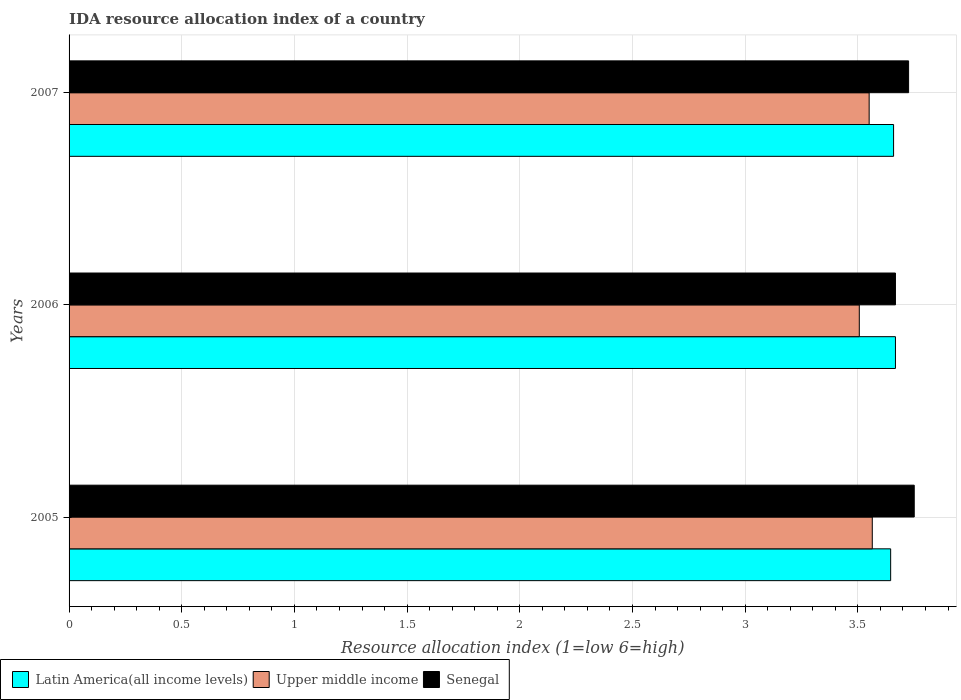How many groups of bars are there?
Make the answer very short. 3. Are the number of bars on each tick of the Y-axis equal?
Your answer should be compact. Yes. In how many cases, is the number of bars for a given year not equal to the number of legend labels?
Your answer should be very brief. 0. What is the IDA resource allocation index in Upper middle income in 2007?
Ensure brevity in your answer.  3.55. Across all years, what is the maximum IDA resource allocation index in Upper middle income?
Keep it short and to the point. 3.56. Across all years, what is the minimum IDA resource allocation index in Senegal?
Provide a succinct answer. 3.67. In which year was the IDA resource allocation index in Latin America(all income levels) minimum?
Your response must be concise. 2005. What is the total IDA resource allocation index in Senegal in the graph?
Keep it short and to the point. 11.14. What is the difference between the IDA resource allocation index in Senegal in 2006 and that in 2007?
Ensure brevity in your answer.  -0.06. What is the difference between the IDA resource allocation index in Latin America(all income levels) in 2006 and the IDA resource allocation index in Upper middle income in 2005?
Give a very brief answer. 0.1. What is the average IDA resource allocation index in Upper middle income per year?
Provide a succinct answer. 3.54. In the year 2005, what is the difference between the IDA resource allocation index in Upper middle income and IDA resource allocation index in Latin America(all income levels)?
Keep it short and to the point. -0.08. In how many years, is the IDA resource allocation index in Senegal greater than 2.8 ?
Offer a terse response. 3. What is the ratio of the IDA resource allocation index in Senegal in 2005 to that in 2007?
Offer a very short reply. 1.01. Is the IDA resource allocation index in Latin America(all income levels) in 2005 less than that in 2006?
Give a very brief answer. Yes. Is the difference between the IDA resource allocation index in Upper middle income in 2005 and 2007 greater than the difference between the IDA resource allocation index in Latin America(all income levels) in 2005 and 2007?
Your answer should be very brief. Yes. What is the difference between the highest and the second highest IDA resource allocation index in Senegal?
Provide a succinct answer. 0.02. What is the difference between the highest and the lowest IDA resource allocation index in Senegal?
Provide a succinct answer. 0.08. In how many years, is the IDA resource allocation index in Upper middle income greater than the average IDA resource allocation index in Upper middle income taken over all years?
Provide a short and direct response. 2. Is the sum of the IDA resource allocation index in Latin America(all income levels) in 2005 and 2007 greater than the maximum IDA resource allocation index in Upper middle income across all years?
Give a very brief answer. Yes. What does the 2nd bar from the top in 2005 represents?
Provide a succinct answer. Upper middle income. What does the 1st bar from the bottom in 2007 represents?
Give a very brief answer. Latin America(all income levels). How many bars are there?
Your answer should be very brief. 9. Are all the bars in the graph horizontal?
Ensure brevity in your answer.  Yes. What is the difference between two consecutive major ticks on the X-axis?
Keep it short and to the point. 0.5. Are the values on the major ticks of X-axis written in scientific E-notation?
Your answer should be very brief. No. Does the graph contain any zero values?
Keep it short and to the point. No. Does the graph contain grids?
Provide a succinct answer. Yes. How many legend labels are there?
Your answer should be compact. 3. How are the legend labels stacked?
Offer a very short reply. Horizontal. What is the title of the graph?
Make the answer very short. IDA resource allocation index of a country. What is the label or title of the X-axis?
Provide a short and direct response. Resource allocation index (1=low 6=high). What is the label or title of the Y-axis?
Offer a terse response. Years. What is the Resource allocation index (1=low 6=high) in Latin America(all income levels) in 2005?
Provide a short and direct response. 3.65. What is the Resource allocation index (1=low 6=high) of Upper middle income in 2005?
Offer a very short reply. 3.56. What is the Resource allocation index (1=low 6=high) of Senegal in 2005?
Your answer should be compact. 3.75. What is the Resource allocation index (1=low 6=high) of Latin America(all income levels) in 2006?
Provide a short and direct response. 3.67. What is the Resource allocation index (1=low 6=high) in Upper middle income in 2006?
Keep it short and to the point. 3.51. What is the Resource allocation index (1=low 6=high) of Senegal in 2006?
Give a very brief answer. 3.67. What is the Resource allocation index (1=low 6=high) of Latin America(all income levels) in 2007?
Your answer should be compact. 3.66. What is the Resource allocation index (1=low 6=high) of Upper middle income in 2007?
Offer a terse response. 3.55. What is the Resource allocation index (1=low 6=high) in Senegal in 2007?
Give a very brief answer. 3.73. Across all years, what is the maximum Resource allocation index (1=low 6=high) in Latin America(all income levels)?
Keep it short and to the point. 3.67. Across all years, what is the maximum Resource allocation index (1=low 6=high) in Upper middle income?
Offer a very short reply. 3.56. Across all years, what is the maximum Resource allocation index (1=low 6=high) of Senegal?
Provide a succinct answer. 3.75. Across all years, what is the minimum Resource allocation index (1=low 6=high) in Latin America(all income levels)?
Offer a terse response. 3.65. Across all years, what is the minimum Resource allocation index (1=low 6=high) of Upper middle income?
Provide a succinct answer. 3.51. Across all years, what is the minimum Resource allocation index (1=low 6=high) of Senegal?
Offer a terse response. 3.67. What is the total Resource allocation index (1=low 6=high) in Latin America(all income levels) in the graph?
Provide a succinct answer. 10.97. What is the total Resource allocation index (1=low 6=high) in Upper middle income in the graph?
Ensure brevity in your answer.  10.62. What is the total Resource allocation index (1=low 6=high) in Senegal in the graph?
Keep it short and to the point. 11.14. What is the difference between the Resource allocation index (1=low 6=high) of Latin America(all income levels) in 2005 and that in 2006?
Give a very brief answer. -0.02. What is the difference between the Resource allocation index (1=low 6=high) in Upper middle income in 2005 and that in 2006?
Provide a short and direct response. 0.06. What is the difference between the Resource allocation index (1=low 6=high) in Senegal in 2005 and that in 2006?
Ensure brevity in your answer.  0.08. What is the difference between the Resource allocation index (1=low 6=high) of Latin America(all income levels) in 2005 and that in 2007?
Offer a very short reply. -0.01. What is the difference between the Resource allocation index (1=low 6=high) of Upper middle income in 2005 and that in 2007?
Your answer should be very brief. 0.01. What is the difference between the Resource allocation index (1=low 6=high) in Senegal in 2005 and that in 2007?
Provide a succinct answer. 0.03. What is the difference between the Resource allocation index (1=low 6=high) of Latin America(all income levels) in 2006 and that in 2007?
Make the answer very short. 0.01. What is the difference between the Resource allocation index (1=low 6=high) in Upper middle income in 2006 and that in 2007?
Make the answer very short. -0.04. What is the difference between the Resource allocation index (1=low 6=high) in Senegal in 2006 and that in 2007?
Make the answer very short. -0.06. What is the difference between the Resource allocation index (1=low 6=high) in Latin America(all income levels) in 2005 and the Resource allocation index (1=low 6=high) in Upper middle income in 2006?
Provide a succinct answer. 0.14. What is the difference between the Resource allocation index (1=low 6=high) of Latin America(all income levels) in 2005 and the Resource allocation index (1=low 6=high) of Senegal in 2006?
Your answer should be compact. -0.02. What is the difference between the Resource allocation index (1=low 6=high) in Upper middle income in 2005 and the Resource allocation index (1=low 6=high) in Senegal in 2006?
Keep it short and to the point. -0.1. What is the difference between the Resource allocation index (1=low 6=high) of Latin America(all income levels) in 2005 and the Resource allocation index (1=low 6=high) of Upper middle income in 2007?
Provide a succinct answer. 0.1. What is the difference between the Resource allocation index (1=low 6=high) in Latin America(all income levels) in 2005 and the Resource allocation index (1=low 6=high) in Senegal in 2007?
Make the answer very short. -0.08. What is the difference between the Resource allocation index (1=low 6=high) of Upper middle income in 2005 and the Resource allocation index (1=low 6=high) of Senegal in 2007?
Ensure brevity in your answer.  -0.16. What is the difference between the Resource allocation index (1=low 6=high) in Latin America(all income levels) in 2006 and the Resource allocation index (1=low 6=high) in Upper middle income in 2007?
Provide a succinct answer. 0.12. What is the difference between the Resource allocation index (1=low 6=high) in Latin America(all income levels) in 2006 and the Resource allocation index (1=low 6=high) in Senegal in 2007?
Provide a succinct answer. -0.06. What is the difference between the Resource allocation index (1=low 6=high) in Upper middle income in 2006 and the Resource allocation index (1=low 6=high) in Senegal in 2007?
Your answer should be compact. -0.22. What is the average Resource allocation index (1=low 6=high) in Latin America(all income levels) per year?
Your answer should be compact. 3.66. What is the average Resource allocation index (1=low 6=high) of Upper middle income per year?
Offer a very short reply. 3.54. What is the average Resource allocation index (1=low 6=high) in Senegal per year?
Offer a very short reply. 3.71. In the year 2005, what is the difference between the Resource allocation index (1=low 6=high) in Latin America(all income levels) and Resource allocation index (1=low 6=high) in Upper middle income?
Make the answer very short. 0.08. In the year 2005, what is the difference between the Resource allocation index (1=low 6=high) in Latin America(all income levels) and Resource allocation index (1=low 6=high) in Senegal?
Provide a short and direct response. -0.1. In the year 2005, what is the difference between the Resource allocation index (1=low 6=high) of Upper middle income and Resource allocation index (1=low 6=high) of Senegal?
Keep it short and to the point. -0.19. In the year 2006, what is the difference between the Resource allocation index (1=low 6=high) in Latin America(all income levels) and Resource allocation index (1=low 6=high) in Upper middle income?
Offer a very short reply. 0.16. In the year 2006, what is the difference between the Resource allocation index (1=low 6=high) of Latin America(all income levels) and Resource allocation index (1=low 6=high) of Senegal?
Keep it short and to the point. 0. In the year 2006, what is the difference between the Resource allocation index (1=low 6=high) of Upper middle income and Resource allocation index (1=low 6=high) of Senegal?
Make the answer very short. -0.16. In the year 2007, what is the difference between the Resource allocation index (1=low 6=high) in Latin America(all income levels) and Resource allocation index (1=low 6=high) in Upper middle income?
Provide a short and direct response. 0.11. In the year 2007, what is the difference between the Resource allocation index (1=low 6=high) of Latin America(all income levels) and Resource allocation index (1=low 6=high) of Senegal?
Offer a very short reply. -0.07. In the year 2007, what is the difference between the Resource allocation index (1=low 6=high) in Upper middle income and Resource allocation index (1=low 6=high) in Senegal?
Offer a very short reply. -0.17. What is the ratio of the Resource allocation index (1=low 6=high) in Upper middle income in 2005 to that in 2006?
Offer a very short reply. 1.02. What is the ratio of the Resource allocation index (1=low 6=high) in Senegal in 2005 to that in 2006?
Provide a succinct answer. 1.02. What is the ratio of the Resource allocation index (1=low 6=high) of Senegal in 2006 to that in 2007?
Provide a short and direct response. 0.98. What is the difference between the highest and the second highest Resource allocation index (1=low 6=high) of Latin America(all income levels)?
Provide a succinct answer. 0.01. What is the difference between the highest and the second highest Resource allocation index (1=low 6=high) of Upper middle income?
Provide a short and direct response. 0.01. What is the difference between the highest and the second highest Resource allocation index (1=low 6=high) in Senegal?
Offer a very short reply. 0.03. What is the difference between the highest and the lowest Resource allocation index (1=low 6=high) of Latin America(all income levels)?
Your answer should be compact. 0.02. What is the difference between the highest and the lowest Resource allocation index (1=low 6=high) in Upper middle income?
Your response must be concise. 0.06. What is the difference between the highest and the lowest Resource allocation index (1=low 6=high) in Senegal?
Provide a succinct answer. 0.08. 